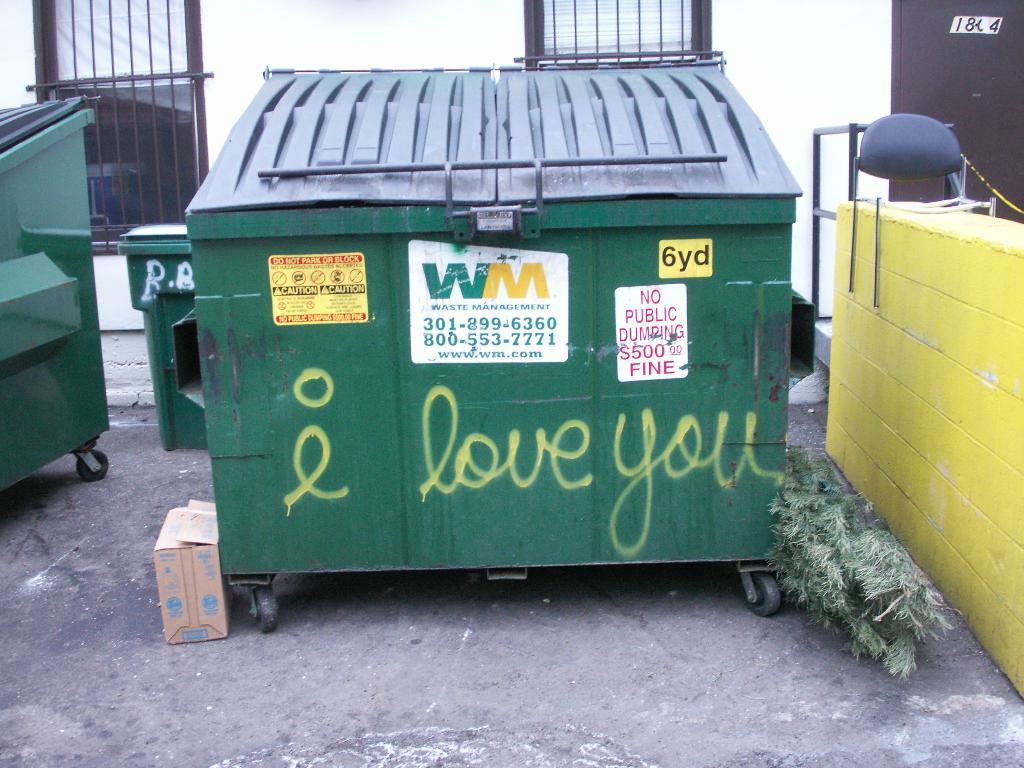<image>
Summarize the visual content of the image. "Love you" is written on a green dumpster outside. 